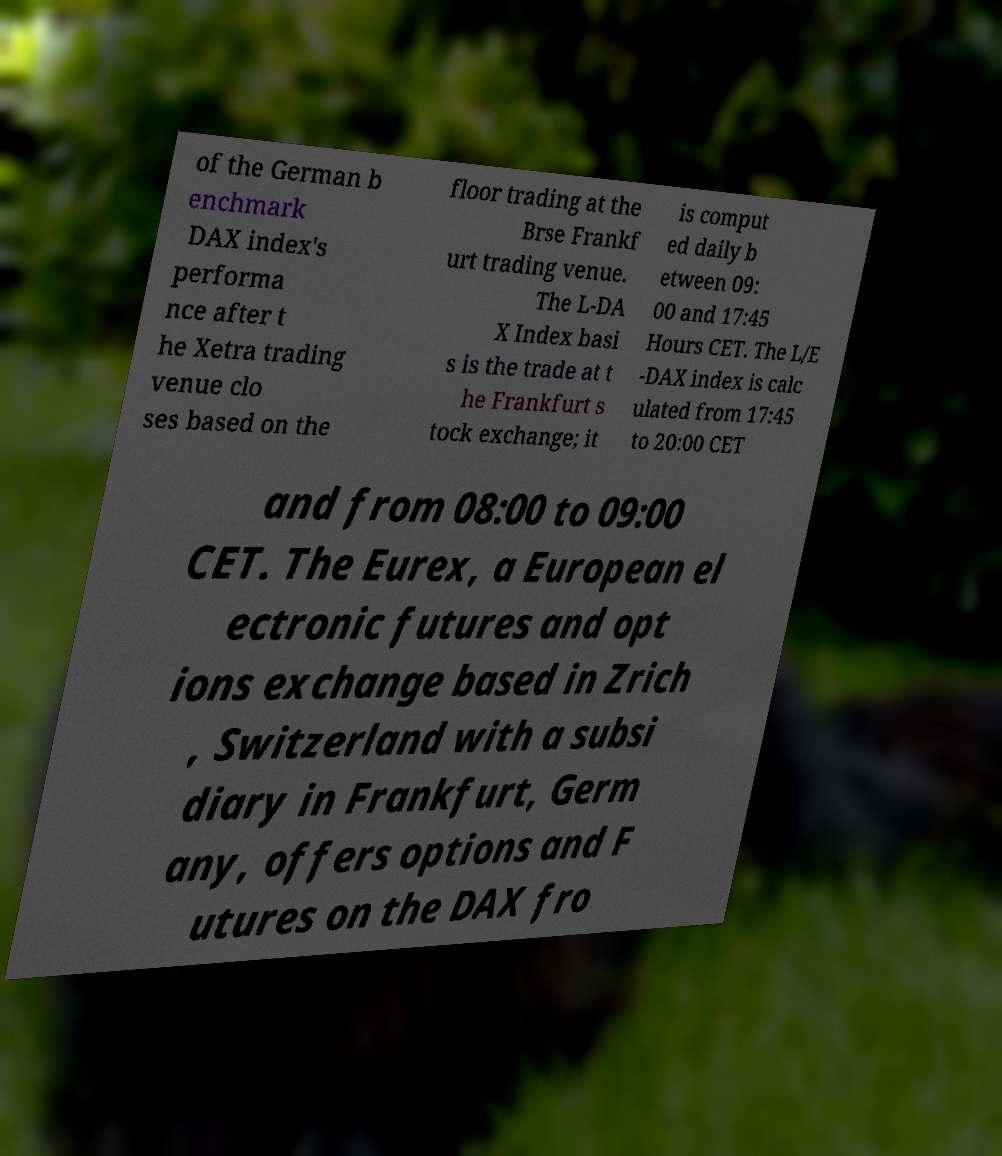I need the written content from this picture converted into text. Can you do that? of the German b enchmark DAX index's performa nce after t he Xetra trading venue clo ses based on the floor trading at the Brse Frankf urt trading venue. The L-DA X Index basi s is the trade at t he Frankfurt s tock exchange; it is comput ed daily b etween 09: 00 and 17:45 Hours CET. The L/E -DAX index is calc ulated from 17:45 to 20:00 CET and from 08:00 to 09:00 CET. The Eurex, a European el ectronic futures and opt ions exchange based in Zrich , Switzerland with a subsi diary in Frankfurt, Germ any, offers options and F utures on the DAX fro 